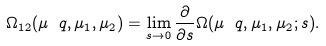Convert formula to latex. <formula><loc_0><loc_0><loc_500><loc_500>\Omega _ { 1 2 } ( \mu _ { \ } q , \mu _ { 1 } , \mu _ { 2 } ) = \lim _ { s \rightarrow 0 } \frac { \partial } { \partial s } \Omega ( \mu _ { \ } q , \mu _ { 1 } , \mu _ { 2 } ; s ) .</formula> 